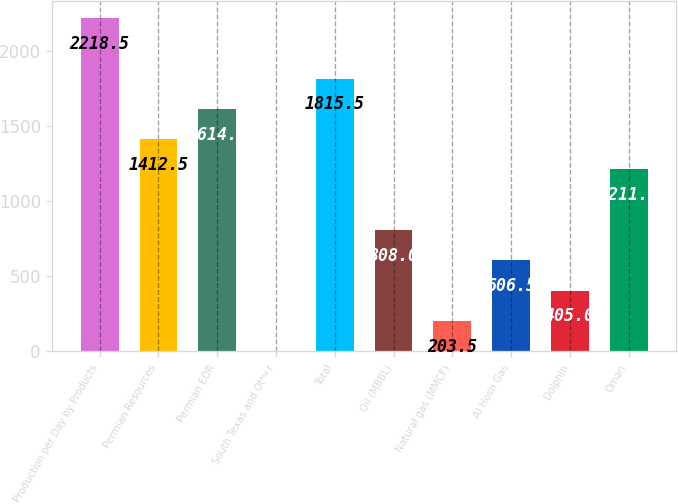Convert chart. <chart><loc_0><loc_0><loc_500><loc_500><bar_chart><fcel>Production per Day by Products<fcel>Permian Resources<fcel>Permian EOR<fcel>South Texas and Other<fcel>Total<fcel>Oil (MBBL)<fcel>Natural gas (MMCF)<fcel>Al Hosn Gas<fcel>Dolphin<fcel>Oman<nl><fcel>2218.5<fcel>1412.5<fcel>1614<fcel>2<fcel>1815.5<fcel>808<fcel>203.5<fcel>606.5<fcel>405<fcel>1211<nl></chart> 